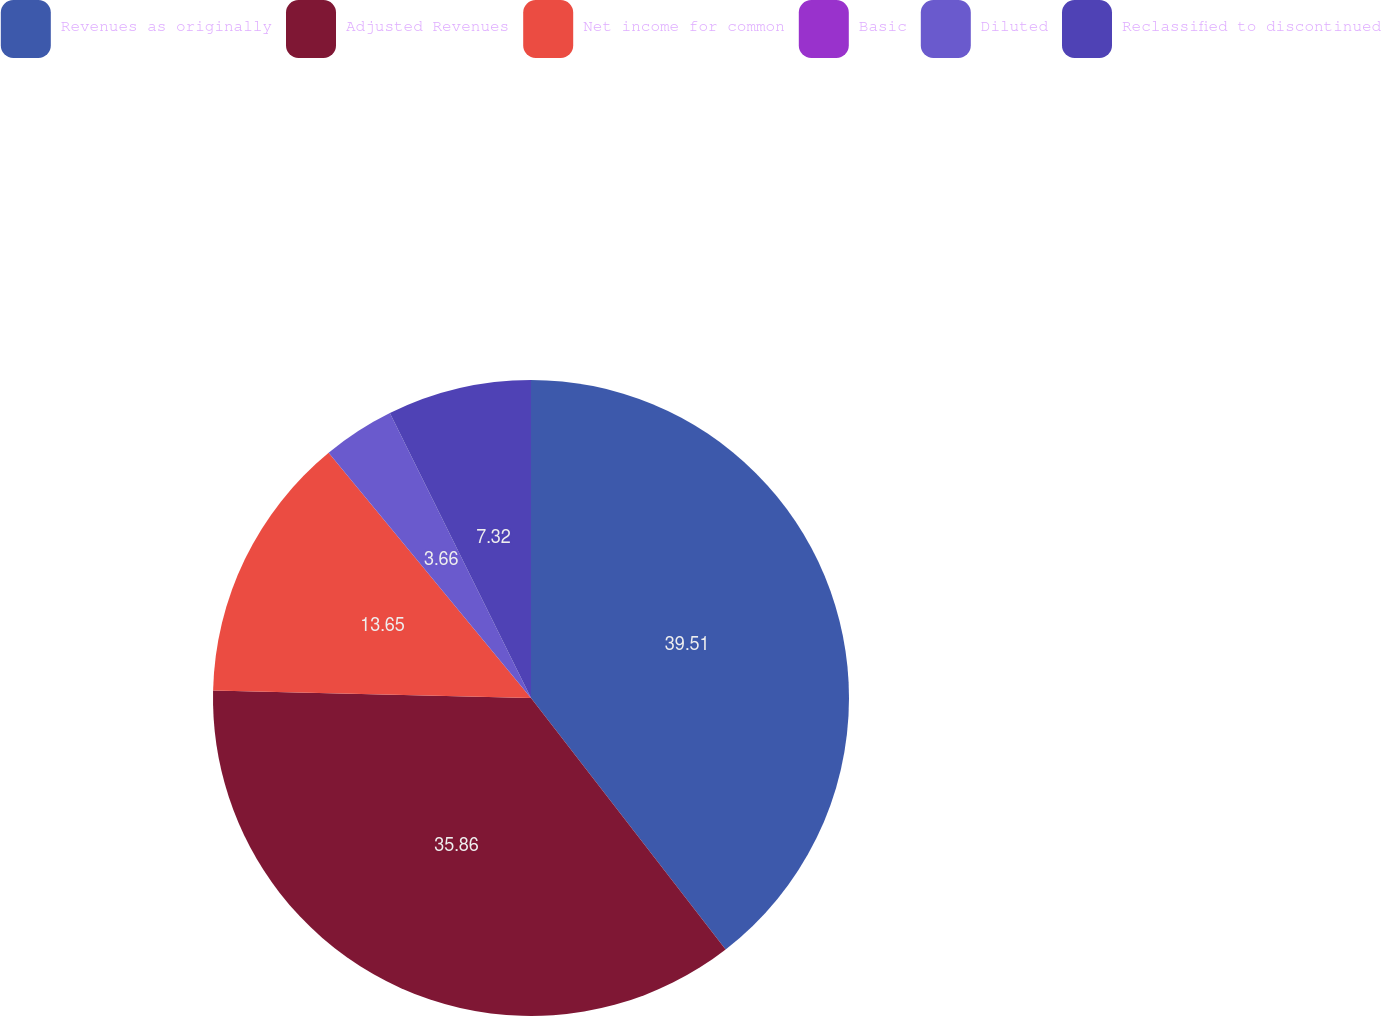<chart> <loc_0><loc_0><loc_500><loc_500><pie_chart><fcel>Revenues as originally<fcel>Adjusted Revenues<fcel>Net income for common<fcel>Basic<fcel>Diluted<fcel>Reclassified to discontinued<nl><fcel>39.52%<fcel>35.86%<fcel>13.65%<fcel>0.0%<fcel>3.66%<fcel>7.32%<nl></chart> 